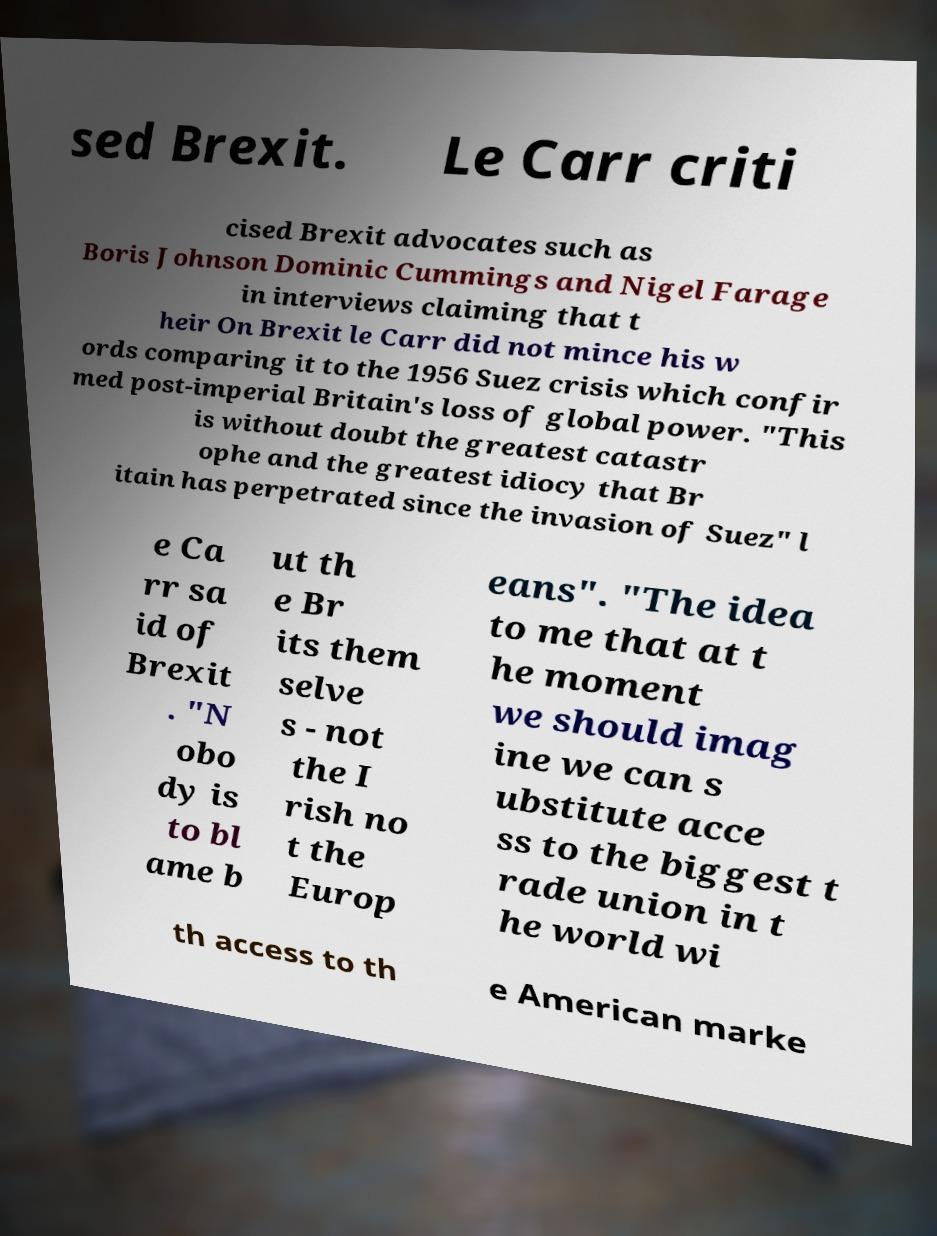What messages or text are displayed in this image? I need them in a readable, typed format. sed Brexit. Le Carr criti cised Brexit advocates such as Boris Johnson Dominic Cummings and Nigel Farage in interviews claiming that t heir On Brexit le Carr did not mince his w ords comparing it to the 1956 Suez crisis which confir med post-imperial Britain's loss of global power. "This is without doubt the greatest catastr ophe and the greatest idiocy that Br itain has perpetrated since the invasion of Suez" l e Ca rr sa id of Brexit . "N obo dy is to bl ame b ut th e Br its them selve s - not the I rish no t the Europ eans". "The idea to me that at t he moment we should imag ine we can s ubstitute acce ss to the biggest t rade union in t he world wi th access to th e American marke 